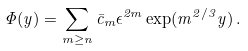Convert formula to latex. <formula><loc_0><loc_0><loc_500><loc_500>\Phi ( y ) = \sum _ { m \geq n } \bar { c } _ { m } \epsilon ^ { 2 m } \exp ( m ^ { 2 / 3 } y ) \, .</formula> 